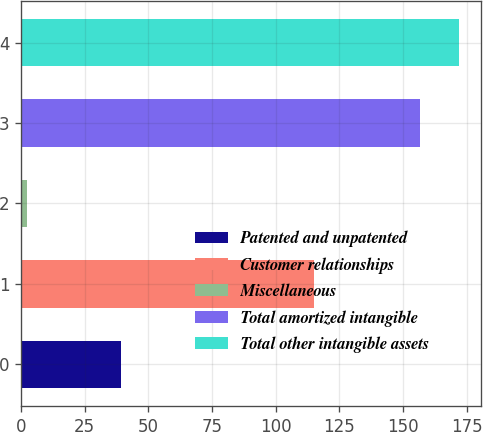Convert chart. <chart><loc_0><loc_0><loc_500><loc_500><bar_chart><fcel>Patented and unpatented<fcel>Customer relationships<fcel>Miscellaneous<fcel>Total amortized intangible<fcel>Total other intangible assets<nl><fcel>39.1<fcel>115.1<fcel>2.5<fcel>156.7<fcel>172.12<nl></chart> 